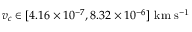Convert formula to latex. <formula><loc_0><loc_0><loc_500><loc_500>v _ { c } \in [ 4 . 1 6 \times 1 0 ^ { - 7 } , 8 . 3 2 \times 1 0 ^ { - 6 } ] \ k m \ s ^ { - 1 }</formula> 